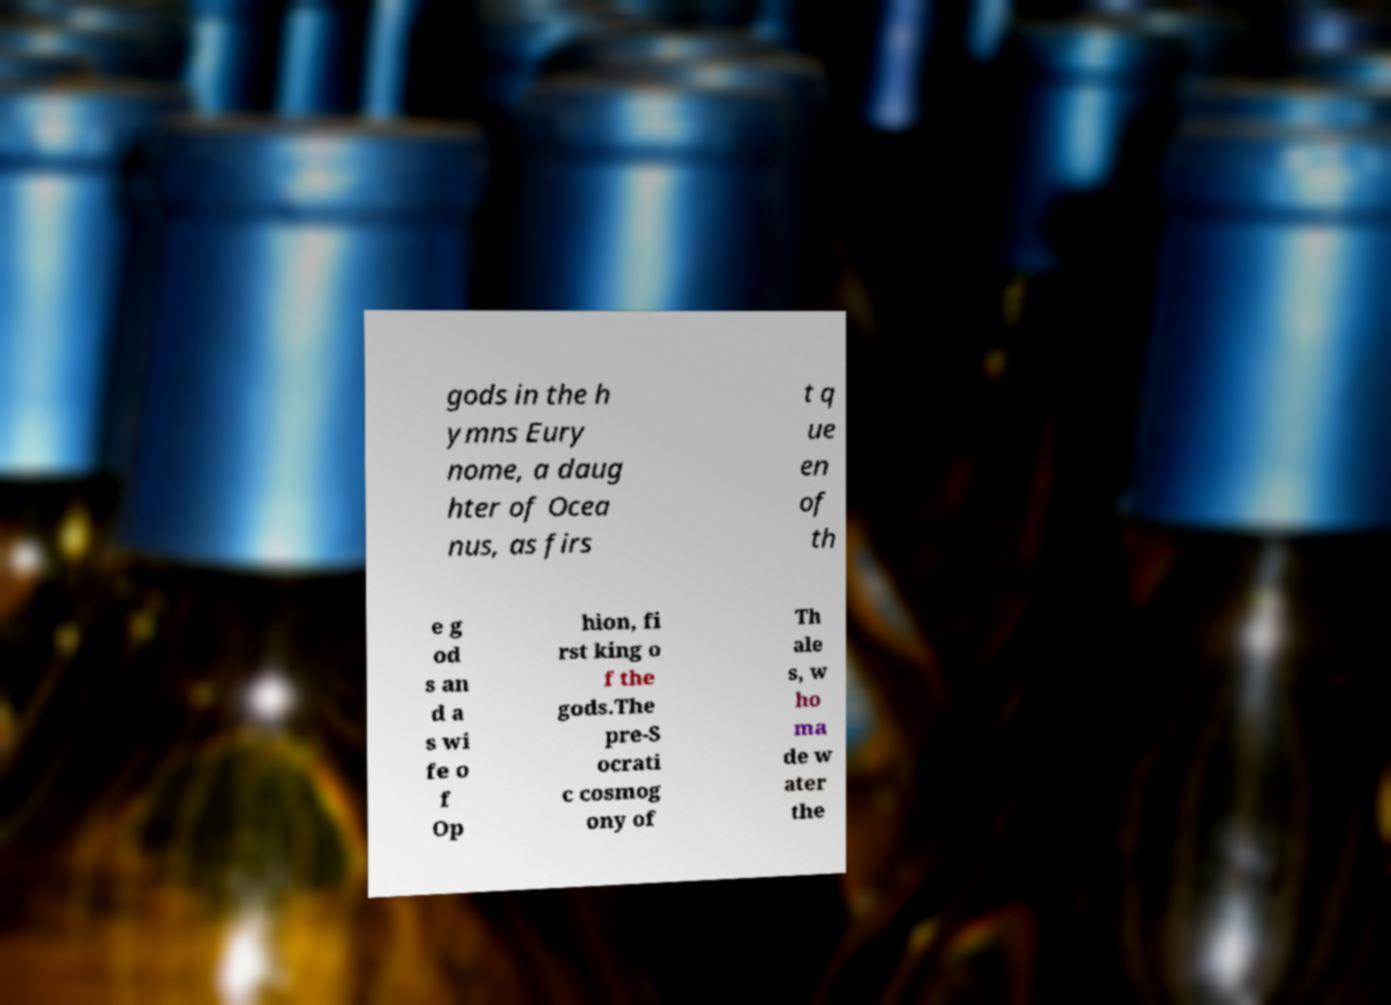Can you accurately transcribe the text from the provided image for me? gods in the h ymns Eury nome, a daug hter of Ocea nus, as firs t q ue en of th e g od s an d a s wi fe o f Op hion, fi rst king o f the gods.The pre-S ocrati c cosmog ony of Th ale s, w ho ma de w ater the 